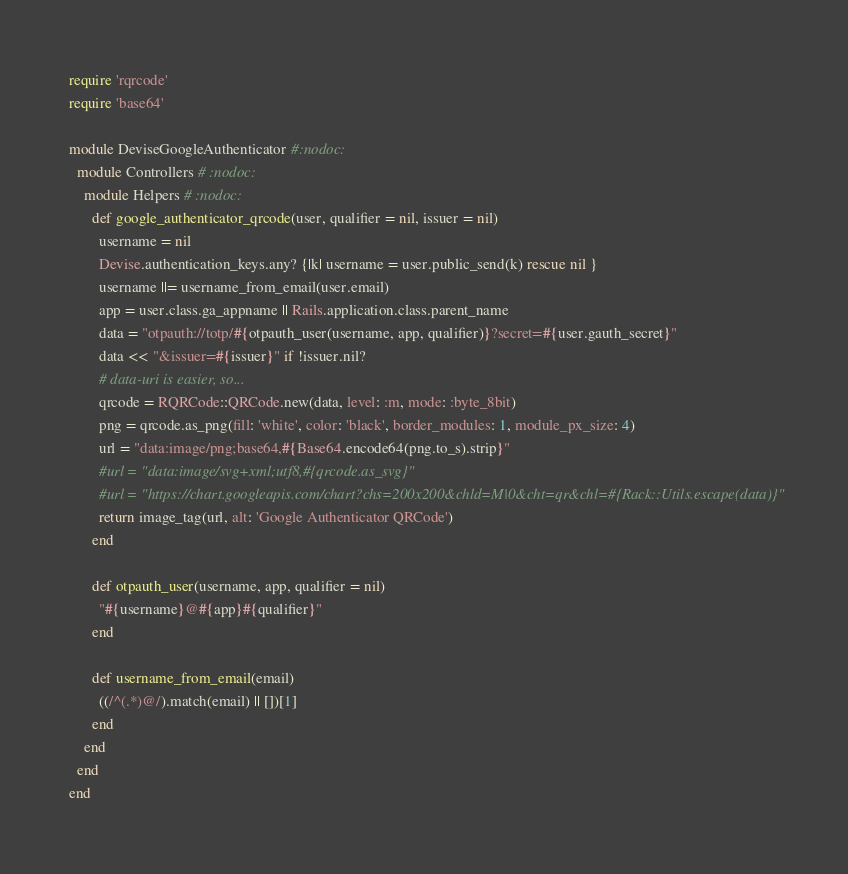Convert code to text. <code><loc_0><loc_0><loc_500><loc_500><_Ruby_>require 'rqrcode'
require 'base64'

module DeviseGoogleAuthenticator #:nodoc:
  module Controllers # :nodoc:
    module Helpers # :nodoc:
      def google_authenticator_qrcode(user, qualifier = nil, issuer = nil)
        username = nil
        Devise.authentication_keys.any? {|k| username = user.public_send(k) rescue nil }
        username ||= username_from_email(user.email)
        app = user.class.ga_appname || Rails.application.class.parent_name
        data = "otpauth://totp/#{otpauth_user(username, app, qualifier)}?secret=#{user.gauth_secret}"
        data << "&issuer=#{issuer}" if !issuer.nil?
        # data-uri is easier, so...
        qrcode = RQRCode::QRCode.new(data, level: :m, mode: :byte_8bit)
        png = qrcode.as_png(fill: 'white', color: 'black', border_modules: 1, module_px_size: 4)
        url = "data:image/png;base64,#{Base64.encode64(png.to_s).strip}"
        #url = "data:image/svg+xml;utf8,#{qrcode.as_svg}"
        #url = "https://chart.googleapis.com/chart?chs=200x200&chld=M|0&cht=qr&chl=#{Rack::Utils.escape(data)}"
        return image_tag(url, alt: 'Google Authenticator QRCode')
      end

      def otpauth_user(username, app, qualifier = nil)
        "#{username}@#{app}#{qualifier}"
      end

      def username_from_email(email)
        ((/^(.*)@/).match(email) || [])[1]
      end
    end
  end
end
</code> 